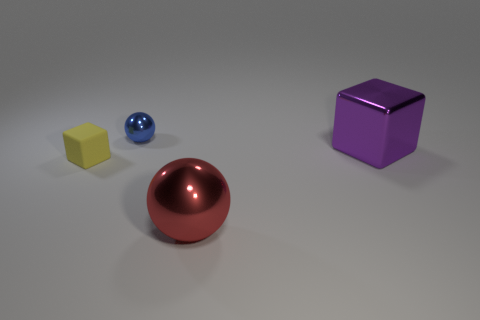How big is the object that is on the left side of the ball that is behind the large metallic thing that is left of the large block?
Ensure brevity in your answer.  Small. There is a small blue object; what shape is it?
Keep it short and to the point. Sphere. There is a red object to the right of the yellow matte block; what number of small yellow cubes are left of it?
Provide a succinct answer. 1. What number of other things are made of the same material as the large cube?
Provide a succinct answer. 2. Is the material of the small thing that is behind the tiny yellow matte cube the same as the tiny object in front of the blue shiny ball?
Provide a short and direct response. No. Is there anything else that has the same shape as the rubber object?
Offer a terse response. Yes. Does the large purple thing have the same material as the sphere that is behind the red metallic sphere?
Make the answer very short. Yes. The metallic thing in front of the object on the right side of the big shiny object in front of the rubber thing is what color?
Give a very brief answer. Red. There is a red metallic thing that is the same size as the shiny block; what is its shape?
Keep it short and to the point. Sphere. Is there anything else that is the same size as the matte cube?
Provide a succinct answer. Yes. 